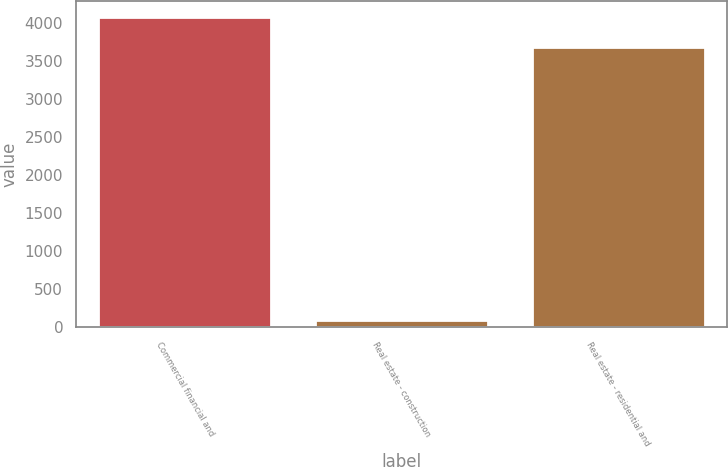<chart> <loc_0><loc_0><loc_500><loc_500><bar_chart><fcel>Commercial financial and<fcel>Real estate - construction<fcel>Real estate - residential and<nl><fcel>4086.9<fcel>91<fcel>3693<nl></chart> 